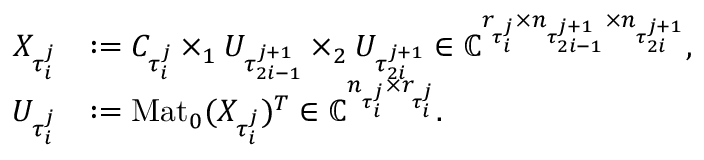<formula> <loc_0><loc_0><loc_500><loc_500>\begin{array} { r l } { X _ { \tau _ { i } ^ { j } } } & { \colon = C _ { \tau _ { i } ^ { j } } \times _ { 1 } U _ { \tau _ { 2 i - 1 } ^ { j + 1 } } \times _ { 2 } U _ { \tau _ { 2 i } ^ { j + 1 } } \in \mathbb { C } ^ { r _ { \tau _ { i } ^ { j } } \times n _ { \tau _ { 2 i - 1 } ^ { j + 1 } } \times n _ { \tau _ { 2 i } ^ { j + 1 } } } , } \\ { U _ { \tau _ { i } ^ { j } } } & { \colon = M a t _ { 0 } ( X _ { \tau _ { i } ^ { j } } ) ^ { T } \in \mathbb { C } ^ { n _ { \tau _ { i } ^ { j } } \times r _ { \tau _ { i } ^ { j } } } . } \end{array}</formula> 